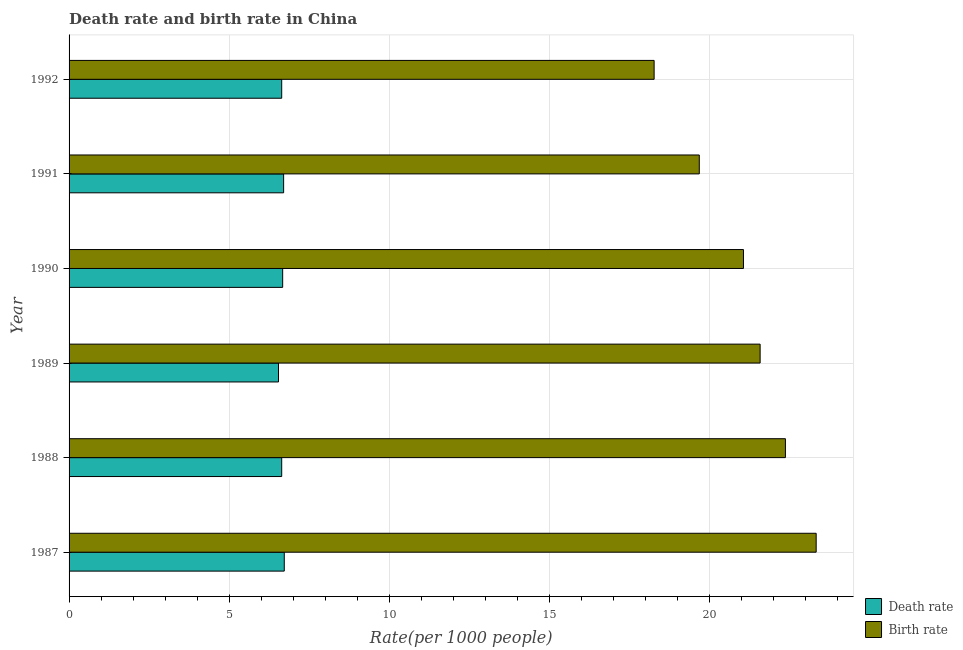What is the label of the 3rd group of bars from the top?
Your response must be concise. 1990. What is the death rate in 1991?
Keep it short and to the point. 6.7. Across all years, what is the maximum birth rate?
Offer a very short reply. 23.33. Across all years, what is the minimum death rate?
Give a very brief answer. 6.54. In which year was the birth rate maximum?
Give a very brief answer. 1987. In which year was the death rate minimum?
Provide a short and direct response. 1989. What is the total death rate in the graph?
Ensure brevity in your answer.  39.91. What is the difference between the death rate in 1989 and the birth rate in 1988?
Make the answer very short. -15.83. What is the average birth rate per year?
Make the answer very short. 21.05. In the year 1988, what is the difference between the death rate and birth rate?
Give a very brief answer. -15.73. In how many years, is the birth rate greater than 7 ?
Give a very brief answer. 6. Is the birth rate in 1988 less than that in 1990?
Offer a terse response. No. Is the difference between the birth rate in 1989 and 1991 greater than the difference between the death rate in 1989 and 1991?
Make the answer very short. Yes. What is the difference between the highest and the lowest death rate?
Your response must be concise. 0.18. Is the sum of the death rate in 1989 and 1990 greater than the maximum birth rate across all years?
Keep it short and to the point. No. What does the 2nd bar from the top in 1988 represents?
Provide a succinct answer. Death rate. What does the 1st bar from the bottom in 1992 represents?
Provide a succinct answer. Death rate. Are all the bars in the graph horizontal?
Provide a succinct answer. Yes. What is the difference between two consecutive major ticks on the X-axis?
Provide a succinct answer. 5. Does the graph contain any zero values?
Make the answer very short. No. Where does the legend appear in the graph?
Give a very brief answer. Bottom right. What is the title of the graph?
Ensure brevity in your answer.  Death rate and birth rate in China. What is the label or title of the X-axis?
Your answer should be very brief. Rate(per 1000 people). What is the label or title of the Y-axis?
Provide a short and direct response. Year. What is the Rate(per 1000 people) of Death rate in 1987?
Ensure brevity in your answer.  6.72. What is the Rate(per 1000 people) in Birth rate in 1987?
Keep it short and to the point. 23.33. What is the Rate(per 1000 people) in Death rate in 1988?
Make the answer very short. 6.64. What is the Rate(per 1000 people) in Birth rate in 1988?
Ensure brevity in your answer.  22.37. What is the Rate(per 1000 people) in Death rate in 1989?
Ensure brevity in your answer.  6.54. What is the Rate(per 1000 people) in Birth rate in 1989?
Your response must be concise. 21.58. What is the Rate(per 1000 people) in Death rate in 1990?
Provide a short and direct response. 6.67. What is the Rate(per 1000 people) of Birth rate in 1990?
Give a very brief answer. 21.06. What is the Rate(per 1000 people) in Death rate in 1991?
Ensure brevity in your answer.  6.7. What is the Rate(per 1000 people) of Birth rate in 1991?
Your answer should be very brief. 19.68. What is the Rate(per 1000 people) in Death rate in 1992?
Keep it short and to the point. 6.64. What is the Rate(per 1000 people) in Birth rate in 1992?
Provide a short and direct response. 18.27. Across all years, what is the maximum Rate(per 1000 people) of Death rate?
Your response must be concise. 6.72. Across all years, what is the maximum Rate(per 1000 people) in Birth rate?
Your answer should be very brief. 23.33. Across all years, what is the minimum Rate(per 1000 people) of Death rate?
Provide a succinct answer. 6.54. Across all years, what is the minimum Rate(per 1000 people) of Birth rate?
Your answer should be compact. 18.27. What is the total Rate(per 1000 people) of Death rate in the graph?
Give a very brief answer. 39.91. What is the total Rate(per 1000 people) in Birth rate in the graph?
Your answer should be very brief. 126.29. What is the difference between the Rate(per 1000 people) in Death rate in 1987 and that in 1988?
Provide a succinct answer. 0.08. What is the difference between the Rate(per 1000 people) of Birth rate in 1987 and that in 1988?
Offer a very short reply. 0.96. What is the difference between the Rate(per 1000 people) in Death rate in 1987 and that in 1989?
Keep it short and to the point. 0.18. What is the difference between the Rate(per 1000 people) in Birth rate in 1987 and that in 1990?
Provide a short and direct response. 2.27. What is the difference between the Rate(per 1000 people) in Death rate in 1987 and that in 1991?
Provide a succinct answer. 0.02. What is the difference between the Rate(per 1000 people) of Birth rate in 1987 and that in 1991?
Offer a very short reply. 3.65. What is the difference between the Rate(per 1000 people) in Death rate in 1987 and that in 1992?
Give a very brief answer. 0.08. What is the difference between the Rate(per 1000 people) in Birth rate in 1987 and that in 1992?
Provide a succinct answer. 5.06. What is the difference between the Rate(per 1000 people) of Death rate in 1988 and that in 1989?
Provide a short and direct response. 0.1. What is the difference between the Rate(per 1000 people) of Birth rate in 1988 and that in 1989?
Provide a succinct answer. 0.79. What is the difference between the Rate(per 1000 people) in Death rate in 1988 and that in 1990?
Provide a short and direct response. -0.03. What is the difference between the Rate(per 1000 people) of Birth rate in 1988 and that in 1990?
Ensure brevity in your answer.  1.31. What is the difference between the Rate(per 1000 people) in Death rate in 1988 and that in 1991?
Provide a succinct answer. -0.06. What is the difference between the Rate(per 1000 people) in Birth rate in 1988 and that in 1991?
Provide a short and direct response. 2.69. What is the difference between the Rate(per 1000 people) of Death rate in 1989 and that in 1990?
Keep it short and to the point. -0.13. What is the difference between the Rate(per 1000 people) in Birth rate in 1989 and that in 1990?
Offer a very short reply. 0.52. What is the difference between the Rate(per 1000 people) of Death rate in 1989 and that in 1991?
Provide a succinct answer. -0.16. What is the difference between the Rate(per 1000 people) in Birth rate in 1989 and that in 1992?
Keep it short and to the point. 3.31. What is the difference between the Rate(per 1000 people) in Death rate in 1990 and that in 1991?
Ensure brevity in your answer.  -0.03. What is the difference between the Rate(per 1000 people) in Birth rate in 1990 and that in 1991?
Provide a short and direct response. 1.38. What is the difference between the Rate(per 1000 people) in Birth rate in 1990 and that in 1992?
Provide a succinct answer. 2.79. What is the difference between the Rate(per 1000 people) of Death rate in 1991 and that in 1992?
Your answer should be compact. 0.06. What is the difference between the Rate(per 1000 people) in Birth rate in 1991 and that in 1992?
Give a very brief answer. 1.41. What is the difference between the Rate(per 1000 people) of Death rate in 1987 and the Rate(per 1000 people) of Birth rate in 1988?
Provide a succinct answer. -15.65. What is the difference between the Rate(per 1000 people) in Death rate in 1987 and the Rate(per 1000 people) in Birth rate in 1989?
Your response must be concise. -14.86. What is the difference between the Rate(per 1000 people) in Death rate in 1987 and the Rate(per 1000 people) in Birth rate in 1990?
Offer a very short reply. -14.34. What is the difference between the Rate(per 1000 people) of Death rate in 1987 and the Rate(per 1000 people) of Birth rate in 1991?
Your response must be concise. -12.96. What is the difference between the Rate(per 1000 people) in Death rate in 1987 and the Rate(per 1000 people) in Birth rate in 1992?
Keep it short and to the point. -11.55. What is the difference between the Rate(per 1000 people) in Death rate in 1988 and the Rate(per 1000 people) in Birth rate in 1989?
Offer a terse response. -14.94. What is the difference between the Rate(per 1000 people) in Death rate in 1988 and the Rate(per 1000 people) in Birth rate in 1990?
Your response must be concise. -14.42. What is the difference between the Rate(per 1000 people) in Death rate in 1988 and the Rate(per 1000 people) in Birth rate in 1991?
Provide a short and direct response. -13.04. What is the difference between the Rate(per 1000 people) in Death rate in 1988 and the Rate(per 1000 people) in Birth rate in 1992?
Offer a very short reply. -11.63. What is the difference between the Rate(per 1000 people) in Death rate in 1989 and the Rate(per 1000 people) in Birth rate in 1990?
Make the answer very short. -14.52. What is the difference between the Rate(per 1000 people) of Death rate in 1989 and the Rate(per 1000 people) of Birth rate in 1991?
Ensure brevity in your answer.  -13.14. What is the difference between the Rate(per 1000 people) of Death rate in 1989 and the Rate(per 1000 people) of Birth rate in 1992?
Your answer should be compact. -11.73. What is the difference between the Rate(per 1000 people) in Death rate in 1990 and the Rate(per 1000 people) in Birth rate in 1991?
Your response must be concise. -13.01. What is the difference between the Rate(per 1000 people) of Death rate in 1991 and the Rate(per 1000 people) of Birth rate in 1992?
Your answer should be very brief. -11.57. What is the average Rate(per 1000 people) of Death rate per year?
Give a very brief answer. 6.65. What is the average Rate(per 1000 people) in Birth rate per year?
Give a very brief answer. 21.05. In the year 1987, what is the difference between the Rate(per 1000 people) of Death rate and Rate(per 1000 people) of Birth rate?
Offer a terse response. -16.61. In the year 1988, what is the difference between the Rate(per 1000 people) of Death rate and Rate(per 1000 people) of Birth rate?
Your answer should be very brief. -15.73. In the year 1989, what is the difference between the Rate(per 1000 people) of Death rate and Rate(per 1000 people) of Birth rate?
Your answer should be very brief. -15.04. In the year 1990, what is the difference between the Rate(per 1000 people) in Death rate and Rate(per 1000 people) in Birth rate?
Ensure brevity in your answer.  -14.39. In the year 1991, what is the difference between the Rate(per 1000 people) of Death rate and Rate(per 1000 people) of Birth rate?
Provide a short and direct response. -12.98. In the year 1992, what is the difference between the Rate(per 1000 people) of Death rate and Rate(per 1000 people) of Birth rate?
Provide a succinct answer. -11.63. What is the ratio of the Rate(per 1000 people) of Death rate in 1987 to that in 1988?
Provide a short and direct response. 1.01. What is the ratio of the Rate(per 1000 people) in Birth rate in 1987 to that in 1988?
Keep it short and to the point. 1.04. What is the ratio of the Rate(per 1000 people) in Death rate in 1987 to that in 1989?
Make the answer very short. 1.03. What is the ratio of the Rate(per 1000 people) of Birth rate in 1987 to that in 1989?
Provide a succinct answer. 1.08. What is the ratio of the Rate(per 1000 people) in Death rate in 1987 to that in 1990?
Your response must be concise. 1.01. What is the ratio of the Rate(per 1000 people) of Birth rate in 1987 to that in 1990?
Keep it short and to the point. 1.11. What is the ratio of the Rate(per 1000 people) in Death rate in 1987 to that in 1991?
Provide a short and direct response. 1. What is the ratio of the Rate(per 1000 people) of Birth rate in 1987 to that in 1991?
Your answer should be compact. 1.19. What is the ratio of the Rate(per 1000 people) in Birth rate in 1987 to that in 1992?
Provide a succinct answer. 1.28. What is the ratio of the Rate(per 1000 people) of Death rate in 1988 to that in 1989?
Give a very brief answer. 1.02. What is the ratio of the Rate(per 1000 people) in Birth rate in 1988 to that in 1989?
Offer a very short reply. 1.04. What is the ratio of the Rate(per 1000 people) in Birth rate in 1988 to that in 1990?
Offer a very short reply. 1.06. What is the ratio of the Rate(per 1000 people) in Death rate in 1988 to that in 1991?
Your answer should be very brief. 0.99. What is the ratio of the Rate(per 1000 people) in Birth rate in 1988 to that in 1991?
Offer a terse response. 1.14. What is the ratio of the Rate(per 1000 people) of Birth rate in 1988 to that in 1992?
Offer a terse response. 1.22. What is the ratio of the Rate(per 1000 people) of Death rate in 1989 to that in 1990?
Offer a very short reply. 0.98. What is the ratio of the Rate(per 1000 people) in Birth rate in 1989 to that in 1990?
Offer a very short reply. 1.02. What is the ratio of the Rate(per 1000 people) of Death rate in 1989 to that in 1991?
Offer a terse response. 0.98. What is the ratio of the Rate(per 1000 people) in Birth rate in 1989 to that in 1991?
Give a very brief answer. 1.1. What is the ratio of the Rate(per 1000 people) in Death rate in 1989 to that in 1992?
Provide a succinct answer. 0.98. What is the ratio of the Rate(per 1000 people) of Birth rate in 1989 to that in 1992?
Offer a terse response. 1.18. What is the ratio of the Rate(per 1000 people) in Death rate in 1990 to that in 1991?
Ensure brevity in your answer.  1. What is the ratio of the Rate(per 1000 people) of Birth rate in 1990 to that in 1991?
Give a very brief answer. 1.07. What is the ratio of the Rate(per 1000 people) in Birth rate in 1990 to that in 1992?
Your answer should be compact. 1.15. What is the ratio of the Rate(per 1000 people) in Death rate in 1991 to that in 1992?
Your answer should be very brief. 1.01. What is the ratio of the Rate(per 1000 people) of Birth rate in 1991 to that in 1992?
Make the answer very short. 1.08. What is the difference between the highest and the second highest Rate(per 1000 people) in Birth rate?
Your answer should be compact. 0.96. What is the difference between the highest and the lowest Rate(per 1000 people) of Death rate?
Give a very brief answer. 0.18. What is the difference between the highest and the lowest Rate(per 1000 people) in Birth rate?
Give a very brief answer. 5.06. 